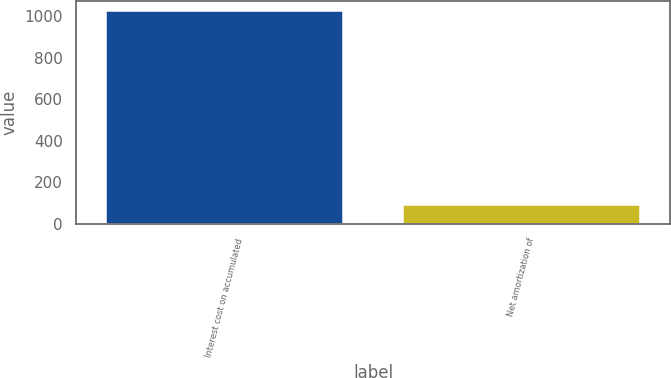Convert chart to OTSL. <chart><loc_0><loc_0><loc_500><loc_500><bar_chart><fcel>Interest cost on accumulated<fcel>Net amortization of<nl><fcel>1022<fcel>88<nl></chart> 